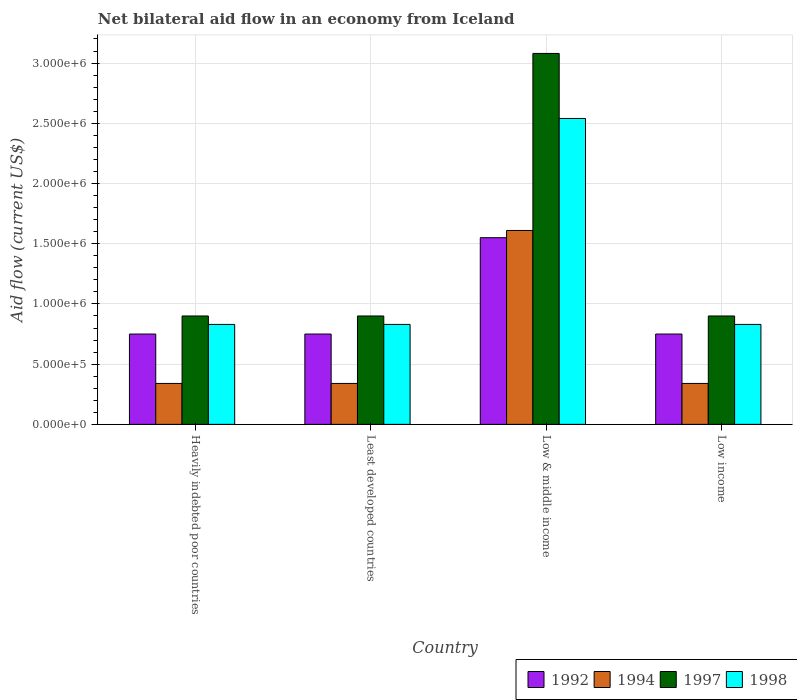How many groups of bars are there?
Provide a short and direct response. 4. How many bars are there on the 2nd tick from the left?
Keep it short and to the point. 4. How many bars are there on the 4th tick from the right?
Offer a very short reply. 4. What is the label of the 1st group of bars from the left?
Keep it short and to the point. Heavily indebted poor countries. In how many cases, is the number of bars for a given country not equal to the number of legend labels?
Give a very brief answer. 0. What is the net bilateral aid flow in 1992 in Least developed countries?
Your response must be concise. 7.50e+05. Across all countries, what is the maximum net bilateral aid flow in 1998?
Ensure brevity in your answer.  2.54e+06. Across all countries, what is the minimum net bilateral aid flow in 1998?
Make the answer very short. 8.30e+05. In which country was the net bilateral aid flow in 1994 minimum?
Your response must be concise. Heavily indebted poor countries. What is the total net bilateral aid flow in 1992 in the graph?
Give a very brief answer. 3.80e+06. What is the difference between the net bilateral aid flow in 1997 in Heavily indebted poor countries and that in Low & middle income?
Provide a short and direct response. -2.18e+06. What is the difference between the net bilateral aid flow in 1997 in Low & middle income and the net bilateral aid flow in 1998 in Heavily indebted poor countries?
Provide a succinct answer. 2.25e+06. What is the average net bilateral aid flow in 1998 per country?
Provide a succinct answer. 1.26e+06. In how many countries, is the net bilateral aid flow in 1997 greater than 2700000 US$?
Your answer should be very brief. 1. What is the difference between the highest and the second highest net bilateral aid flow in 1994?
Keep it short and to the point. 1.27e+06. What is the difference between the highest and the lowest net bilateral aid flow in 1998?
Your response must be concise. 1.71e+06. Is the sum of the net bilateral aid flow in 1998 in Low & middle income and Low income greater than the maximum net bilateral aid flow in 1994 across all countries?
Ensure brevity in your answer.  Yes. What does the 2nd bar from the left in Low & middle income represents?
Ensure brevity in your answer.  1994. What does the 2nd bar from the right in Low & middle income represents?
Your response must be concise. 1997. Is it the case that in every country, the sum of the net bilateral aid flow in 1992 and net bilateral aid flow in 1998 is greater than the net bilateral aid flow in 1997?
Keep it short and to the point. Yes. How many bars are there?
Your response must be concise. 16. How many countries are there in the graph?
Give a very brief answer. 4. Does the graph contain any zero values?
Make the answer very short. No. Does the graph contain grids?
Offer a terse response. Yes. Where does the legend appear in the graph?
Your answer should be compact. Bottom right. What is the title of the graph?
Ensure brevity in your answer.  Net bilateral aid flow in an economy from Iceland. What is the label or title of the X-axis?
Make the answer very short. Country. What is the label or title of the Y-axis?
Offer a very short reply. Aid flow (current US$). What is the Aid flow (current US$) in 1992 in Heavily indebted poor countries?
Give a very brief answer. 7.50e+05. What is the Aid flow (current US$) in 1994 in Heavily indebted poor countries?
Keep it short and to the point. 3.40e+05. What is the Aid flow (current US$) of 1997 in Heavily indebted poor countries?
Provide a succinct answer. 9.00e+05. What is the Aid flow (current US$) of 1998 in Heavily indebted poor countries?
Ensure brevity in your answer.  8.30e+05. What is the Aid flow (current US$) of 1992 in Least developed countries?
Provide a short and direct response. 7.50e+05. What is the Aid flow (current US$) of 1998 in Least developed countries?
Give a very brief answer. 8.30e+05. What is the Aid flow (current US$) of 1992 in Low & middle income?
Offer a very short reply. 1.55e+06. What is the Aid flow (current US$) in 1994 in Low & middle income?
Keep it short and to the point. 1.61e+06. What is the Aid flow (current US$) of 1997 in Low & middle income?
Provide a short and direct response. 3.08e+06. What is the Aid flow (current US$) of 1998 in Low & middle income?
Ensure brevity in your answer.  2.54e+06. What is the Aid flow (current US$) in 1992 in Low income?
Offer a terse response. 7.50e+05. What is the Aid flow (current US$) of 1998 in Low income?
Your answer should be compact. 8.30e+05. Across all countries, what is the maximum Aid flow (current US$) of 1992?
Provide a short and direct response. 1.55e+06. Across all countries, what is the maximum Aid flow (current US$) of 1994?
Ensure brevity in your answer.  1.61e+06. Across all countries, what is the maximum Aid flow (current US$) in 1997?
Keep it short and to the point. 3.08e+06. Across all countries, what is the maximum Aid flow (current US$) in 1998?
Ensure brevity in your answer.  2.54e+06. Across all countries, what is the minimum Aid flow (current US$) in 1992?
Keep it short and to the point. 7.50e+05. Across all countries, what is the minimum Aid flow (current US$) of 1998?
Offer a terse response. 8.30e+05. What is the total Aid flow (current US$) of 1992 in the graph?
Keep it short and to the point. 3.80e+06. What is the total Aid flow (current US$) in 1994 in the graph?
Provide a short and direct response. 2.63e+06. What is the total Aid flow (current US$) of 1997 in the graph?
Your answer should be compact. 5.78e+06. What is the total Aid flow (current US$) of 1998 in the graph?
Give a very brief answer. 5.03e+06. What is the difference between the Aid flow (current US$) in 1992 in Heavily indebted poor countries and that in Low & middle income?
Give a very brief answer. -8.00e+05. What is the difference between the Aid flow (current US$) of 1994 in Heavily indebted poor countries and that in Low & middle income?
Offer a very short reply. -1.27e+06. What is the difference between the Aid flow (current US$) of 1997 in Heavily indebted poor countries and that in Low & middle income?
Offer a terse response. -2.18e+06. What is the difference between the Aid flow (current US$) of 1998 in Heavily indebted poor countries and that in Low & middle income?
Your answer should be very brief. -1.71e+06. What is the difference between the Aid flow (current US$) of 1992 in Heavily indebted poor countries and that in Low income?
Ensure brevity in your answer.  0. What is the difference between the Aid flow (current US$) of 1997 in Heavily indebted poor countries and that in Low income?
Offer a very short reply. 0. What is the difference between the Aid flow (current US$) of 1992 in Least developed countries and that in Low & middle income?
Ensure brevity in your answer.  -8.00e+05. What is the difference between the Aid flow (current US$) of 1994 in Least developed countries and that in Low & middle income?
Your answer should be very brief. -1.27e+06. What is the difference between the Aid flow (current US$) of 1997 in Least developed countries and that in Low & middle income?
Offer a terse response. -2.18e+06. What is the difference between the Aid flow (current US$) of 1998 in Least developed countries and that in Low & middle income?
Ensure brevity in your answer.  -1.71e+06. What is the difference between the Aid flow (current US$) of 1998 in Least developed countries and that in Low income?
Give a very brief answer. 0. What is the difference between the Aid flow (current US$) of 1994 in Low & middle income and that in Low income?
Give a very brief answer. 1.27e+06. What is the difference between the Aid flow (current US$) in 1997 in Low & middle income and that in Low income?
Provide a short and direct response. 2.18e+06. What is the difference between the Aid flow (current US$) of 1998 in Low & middle income and that in Low income?
Your answer should be very brief. 1.71e+06. What is the difference between the Aid flow (current US$) of 1992 in Heavily indebted poor countries and the Aid flow (current US$) of 1998 in Least developed countries?
Offer a terse response. -8.00e+04. What is the difference between the Aid flow (current US$) of 1994 in Heavily indebted poor countries and the Aid flow (current US$) of 1997 in Least developed countries?
Make the answer very short. -5.60e+05. What is the difference between the Aid flow (current US$) in 1994 in Heavily indebted poor countries and the Aid flow (current US$) in 1998 in Least developed countries?
Provide a succinct answer. -4.90e+05. What is the difference between the Aid flow (current US$) in 1992 in Heavily indebted poor countries and the Aid flow (current US$) in 1994 in Low & middle income?
Offer a terse response. -8.60e+05. What is the difference between the Aid flow (current US$) of 1992 in Heavily indebted poor countries and the Aid flow (current US$) of 1997 in Low & middle income?
Provide a succinct answer. -2.33e+06. What is the difference between the Aid flow (current US$) of 1992 in Heavily indebted poor countries and the Aid flow (current US$) of 1998 in Low & middle income?
Ensure brevity in your answer.  -1.79e+06. What is the difference between the Aid flow (current US$) of 1994 in Heavily indebted poor countries and the Aid flow (current US$) of 1997 in Low & middle income?
Offer a very short reply. -2.74e+06. What is the difference between the Aid flow (current US$) in 1994 in Heavily indebted poor countries and the Aid flow (current US$) in 1998 in Low & middle income?
Make the answer very short. -2.20e+06. What is the difference between the Aid flow (current US$) of 1997 in Heavily indebted poor countries and the Aid flow (current US$) of 1998 in Low & middle income?
Give a very brief answer. -1.64e+06. What is the difference between the Aid flow (current US$) of 1992 in Heavily indebted poor countries and the Aid flow (current US$) of 1994 in Low income?
Offer a very short reply. 4.10e+05. What is the difference between the Aid flow (current US$) of 1992 in Heavily indebted poor countries and the Aid flow (current US$) of 1997 in Low income?
Make the answer very short. -1.50e+05. What is the difference between the Aid flow (current US$) in 1994 in Heavily indebted poor countries and the Aid flow (current US$) in 1997 in Low income?
Offer a terse response. -5.60e+05. What is the difference between the Aid flow (current US$) in 1994 in Heavily indebted poor countries and the Aid flow (current US$) in 1998 in Low income?
Give a very brief answer. -4.90e+05. What is the difference between the Aid flow (current US$) in 1997 in Heavily indebted poor countries and the Aid flow (current US$) in 1998 in Low income?
Offer a very short reply. 7.00e+04. What is the difference between the Aid flow (current US$) of 1992 in Least developed countries and the Aid flow (current US$) of 1994 in Low & middle income?
Keep it short and to the point. -8.60e+05. What is the difference between the Aid flow (current US$) in 1992 in Least developed countries and the Aid flow (current US$) in 1997 in Low & middle income?
Provide a succinct answer. -2.33e+06. What is the difference between the Aid flow (current US$) of 1992 in Least developed countries and the Aid flow (current US$) of 1998 in Low & middle income?
Make the answer very short. -1.79e+06. What is the difference between the Aid flow (current US$) of 1994 in Least developed countries and the Aid flow (current US$) of 1997 in Low & middle income?
Your answer should be very brief. -2.74e+06. What is the difference between the Aid flow (current US$) of 1994 in Least developed countries and the Aid flow (current US$) of 1998 in Low & middle income?
Offer a terse response. -2.20e+06. What is the difference between the Aid flow (current US$) of 1997 in Least developed countries and the Aid flow (current US$) of 1998 in Low & middle income?
Offer a terse response. -1.64e+06. What is the difference between the Aid flow (current US$) in 1992 in Least developed countries and the Aid flow (current US$) in 1998 in Low income?
Offer a very short reply. -8.00e+04. What is the difference between the Aid flow (current US$) of 1994 in Least developed countries and the Aid flow (current US$) of 1997 in Low income?
Provide a short and direct response. -5.60e+05. What is the difference between the Aid flow (current US$) in 1994 in Least developed countries and the Aid flow (current US$) in 1998 in Low income?
Keep it short and to the point. -4.90e+05. What is the difference between the Aid flow (current US$) of 1997 in Least developed countries and the Aid flow (current US$) of 1998 in Low income?
Offer a very short reply. 7.00e+04. What is the difference between the Aid flow (current US$) of 1992 in Low & middle income and the Aid flow (current US$) of 1994 in Low income?
Keep it short and to the point. 1.21e+06. What is the difference between the Aid flow (current US$) in 1992 in Low & middle income and the Aid flow (current US$) in 1997 in Low income?
Make the answer very short. 6.50e+05. What is the difference between the Aid flow (current US$) in 1992 in Low & middle income and the Aid flow (current US$) in 1998 in Low income?
Ensure brevity in your answer.  7.20e+05. What is the difference between the Aid flow (current US$) in 1994 in Low & middle income and the Aid flow (current US$) in 1997 in Low income?
Ensure brevity in your answer.  7.10e+05. What is the difference between the Aid flow (current US$) in 1994 in Low & middle income and the Aid flow (current US$) in 1998 in Low income?
Your answer should be very brief. 7.80e+05. What is the difference between the Aid flow (current US$) of 1997 in Low & middle income and the Aid flow (current US$) of 1998 in Low income?
Give a very brief answer. 2.25e+06. What is the average Aid flow (current US$) in 1992 per country?
Your response must be concise. 9.50e+05. What is the average Aid flow (current US$) in 1994 per country?
Give a very brief answer. 6.58e+05. What is the average Aid flow (current US$) in 1997 per country?
Offer a very short reply. 1.44e+06. What is the average Aid flow (current US$) of 1998 per country?
Keep it short and to the point. 1.26e+06. What is the difference between the Aid flow (current US$) in 1992 and Aid flow (current US$) in 1994 in Heavily indebted poor countries?
Offer a terse response. 4.10e+05. What is the difference between the Aid flow (current US$) of 1992 and Aid flow (current US$) of 1997 in Heavily indebted poor countries?
Your answer should be compact. -1.50e+05. What is the difference between the Aid flow (current US$) of 1992 and Aid flow (current US$) of 1998 in Heavily indebted poor countries?
Keep it short and to the point. -8.00e+04. What is the difference between the Aid flow (current US$) of 1994 and Aid flow (current US$) of 1997 in Heavily indebted poor countries?
Ensure brevity in your answer.  -5.60e+05. What is the difference between the Aid flow (current US$) in 1994 and Aid flow (current US$) in 1998 in Heavily indebted poor countries?
Offer a terse response. -4.90e+05. What is the difference between the Aid flow (current US$) of 1992 and Aid flow (current US$) of 1994 in Least developed countries?
Your answer should be compact. 4.10e+05. What is the difference between the Aid flow (current US$) in 1992 and Aid flow (current US$) in 1997 in Least developed countries?
Offer a very short reply. -1.50e+05. What is the difference between the Aid flow (current US$) in 1992 and Aid flow (current US$) in 1998 in Least developed countries?
Offer a terse response. -8.00e+04. What is the difference between the Aid flow (current US$) of 1994 and Aid flow (current US$) of 1997 in Least developed countries?
Offer a terse response. -5.60e+05. What is the difference between the Aid flow (current US$) of 1994 and Aid flow (current US$) of 1998 in Least developed countries?
Make the answer very short. -4.90e+05. What is the difference between the Aid flow (current US$) of 1992 and Aid flow (current US$) of 1997 in Low & middle income?
Provide a succinct answer. -1.53e+06. What is the difference between the Aid flow (current US$) of 1992 and Aid flow (current US$) of 1998 in Low & middle income?
Make the answer very short. -9.90e+05. What is the difference between the Aid flow (current US$) of 1994 and Aid flow (current US$) of 1997 in Low & middle income?
Give a very brief answer. -1.47e+06. What is the difference between the Aid flow (current US$) in 1994 and Aid flow (current US$) in 1998 in Low & middle income?
Provide a succinct answer. -9.30e+05. What is the difference between the Aid flow (current US$) of 1997 and Aid flow (current US$) of 1998 in Low & middle income?
Your answer should be very brief. 5.40e+05. What is the difference between the Aid flow (current US$) of 1992 and Aid flow (current US$) of 1994 in Low income?
Make the answer very short. 4.10e+05. What is the difference between the Aid flow (current US$) of 1992 and Aid flow (current US$) of 1997 in Low income?
Give a very brief answer. -1.50e+05. What is the difference between the Aid flow (current US$) of 1994 and Aid flow (current US$) of 1997 in Low income?
Your answer should be very brief. -5.60e+05. What is the difference between the Aid flow (current US$) in 1994 and Aid flow (current US$) in 1998 in Low income?
Ensure brevity in your answer.  -4.90e+05. What is the difference between the Aid flow (current US$) of 1997 and Aid flow (current US$) of 1998 in Low income?
Offer a terse response. 7.00e+04. What is the ratio of the Aid flow (current US$) in 1997 in Heavily indebted poor countries to that in Least developed countries?
Your answer should be compact. 1. What is the ratio of the Aid flow (current US$) of 1998 in Heavily indebted poor countries to that in Least developed countries?
Your response must be concise. 1. What is the ratio of the Aid flow (current US$) in 1992 in Heavily indebted poor countries to that in Low & middle income?
Offer a terse response. 0.48. What is the ratio of the Aid flow (current US$) in 1994 in Heavily indebted poor countries to that in Low & middle income?
Provide a short and direct response. 0.21. What is the ratio of the Aid flow (current US$) in 1997 in Heavily indebted poor countries to that in Low & middle income?
Your answer should be compact. 0.29. What is the ratio of the Aid flow (current US$) of 1998 in Heavily indebted poor countries to that in Low & middle income?
Give a very brief answer. 0.33. What is the ratio of the Aid flow (current US$) in 1994 in Heavily indebted poor countries to that in Low income?
Provide a succinct answer. 1. What is the ratio of the Aid flow (current US$) in 1997 in Heavily indebted poor countries to that in Low income?
Your response must be concise. 1. What is the ratio of the Aid flow (current US$) in 1998 in Heavily indebted poor countries to that in Low income?
Provide a succinct answer. 1. What is the ratio of the Aid flow (current US$) in 1992 in Least developed countries to that in Low & middle income?
Offer a terse response. 0.48. What is the ratio of the Aid flow (current US$) in 1994 in Least developed countries to that in Low & middle income?
Keep it short and to the point. 0.21. What is the ratio of the Aid flow (current US$) in 1997 in Least developed countries to that in Low & middle income?
Provide a succinct answer. 0.29. What is the ratio of the Aid flow (current US$) of 1998 in Least developed countries to that in Low & middle income?
Offer a very short reply. 0.33. What is the ratio of the Aid flow (current US$) in 1994 in Least developed countries to that in Low income?
Offer a very short reply. 1. What is the ratio of the Aid flow (current US$) of 1997 in Least developed countries to that in Low income?
Provide a short and direct response. 1. What is the ratio of the Aid flow (current US$) in 1998 in Least developed countries to that in Low income?
Give a very brief answer. 1. What is the ratio of the Aid flow (current US$) in 1992 in Low & middle income to that in Low income?
Keep it short and to the point. 2.07. What is the ratio of the Aid flow (current US$) of 1994 in Low & middle income to that in Low income?
Your response must be concise. 4.74. What is the ratio of the Aid flow (current US$) of 1997 in Low & middle income to that in Low income?
Provide a succinct answer. 3.42. What is the ratio of the Aid flow (current US$) of 1998 in Low & middle income to that in Low income?
Make the answer very short. 3.06. What is the difference between the highest and the second highest Aid flow (current US$) in 1992?
Offer a terse response. 8.00e+05. What is the difference between the highest and the second highest Aid flow (current US$) in 1994?
Ensure brevity in your answer.  1.27e+06. What is the difference between the highest and the second highest Aid flow (current US$) in 1997?
Offer a terse response. 2.18e+06. What is the difference between the highest and the second highest Aid flow (current US$) in 1998?
Ensure brevity in your answer.  1.71e+06. What is the difference between the highest and the lowest Aid flow (current US$) in 1992?
Offer a very short reply. 8.00e+05. What is the difference between the highest and the lowest Aid flow (current US$) in 1994?
Your answer should be very brief. 1.27e+06. What is the difference between the highest and the lowest Aid flow (current US$) of 1997?
Give a very brief answer. 2.18e+06. What is the difference between the highest and the lowest Aid flow (current US$) of 1998?
Your answer should be very brief. 1.71e+06. 